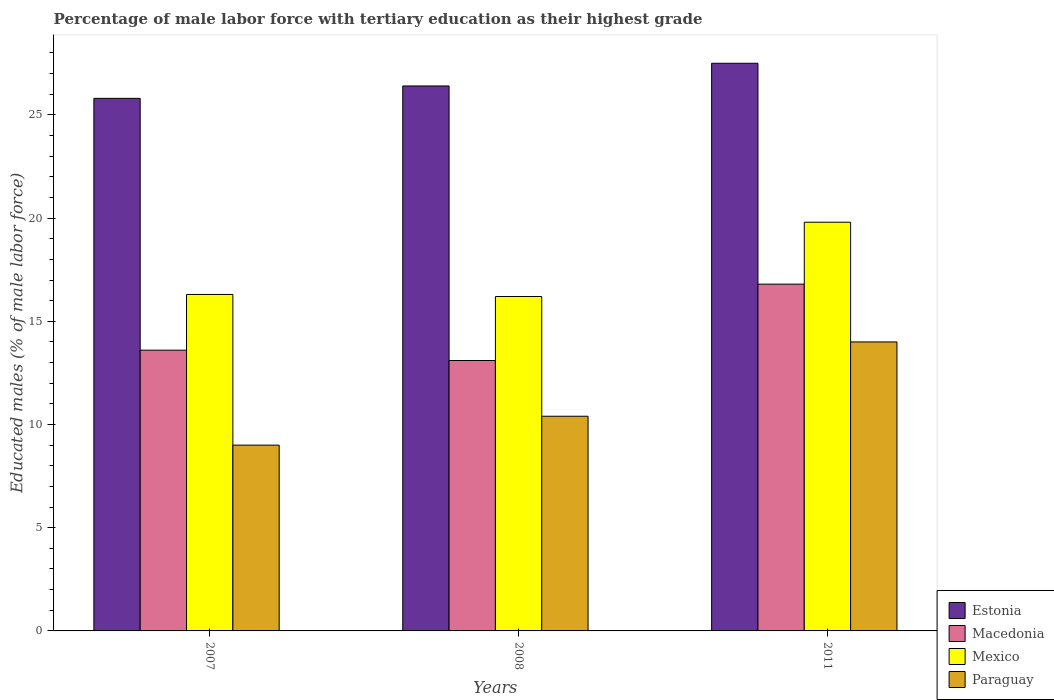How many different coloured bars are there?
Your answer should be compact. 4. Are the number of bars on each tick of the X-axis equal?
Your answer should be compact. Yes. In how many cases, is the number of bars for a given year not equal to the number of legend labels?
Keep it short and to the point. 0. What is the percentage of male labor force with tertiary education in Paraguay in 2011?
Your answer should be compact. 14. Across all years, what is the maximum percentage of male labor force with tertiary education in Macedonia?
Offer a very short reply. 16.8. Across all years, what is the minimum percentage of male labor force with tertiary education in Paraguay?
Offer a very short reply. 9. In which year was the percentage of male labor force with tertiary education in Macedonia maximum?
Offer a terse response. 2011. In which year was the percentage of male labor force with tertiary education in Mexico minimum?
Your response must be concise. 2008. What is the total percentage of male labor force with tertiary education in Macedonia in the graph?
Your answer should be compact. 43.5. What is the difference between the percentage of male labor force with tertiary education in Estonia in 2008 and that in 2011?
Offer a terse response. -1.1. What is the difference between the percentage of male labor force with tertiary education in Macedonia in 2007 and the percentage of male labor force with tertiary education in Mexico in 2011?
Provide a short and direct response. -6.2. What is the average percentage of male labor force with tertiary education in Estonia per year?
Your answer should be compact. 26.57. In the year 2008, what is the difference between the percentage of male labor force with tertiary education in Estonia and percentage of male labor force with tertiary education in Mexico?
Your answer should be very brief. 10.2. In how many years, is the percentage of male labor force with tertiary education in Estonia greater than 19 %?
Make the answer very short. 3. What is the ratio of the percentage of male labor force with tertiary education in Estonia in 2007 to that in 2008?
Give a very brief answer. 0.98. Is the percentage of male labor force with tertiary education in Paraguay in 2007 less than that in 2011?
Offer a terse response. Yes. What is the difference between the highest and the second highest percentage of male labor force with tertiary education in Paraguay?
Make the answer very short. 3.6. What is the difference between the highest and the lowest percentage of male labor force with tertiary education in Paraguay?
Ensure brevity in your answer.  5. What does the 2nd bar from the right in 2008 represents?
Offer a terse response. Mexico. Are all the bars in the graph horizontal?
Your answer should be very brief. No. How many years are there in the graph?
Offer a terse response. 3. Are the values on the major ticks of Y-axis written in scientific E-notation?
Make the answer very short. No. Does the graph contain any zero values?
Provide a succinct answer. No. Does the graph contain grids?
Give a very brief answer. No. How many legend labels are there?
Your response must be concise. 4. What is the title of the graph?
Offer a terse response. Percentage of male labor force with tertiary education as their highest grade. What is the label or title of the X-axis?
Ensure brevity in your answer.  Years. What is the label or title of the Y-axis?
Ensure brevity in your answer.  Educated males (% of male labor force). What is the Educated males (% of male labor force) of Estonia in 2007?
Provide a succinct answer. 25.8. What is the Educated males (% of male labor force) of Macedonia in 2007?
Your response must be concise. 13.6. What is the Educated males (% of male labor force) in Mexico in 2007?
Make the answer very short. 16.3. What is the Educated males (% of male labor force) in Estonia in 2008?
Give a very brief answer. 26.4. What is the Educated males (% of male labor force) in Macedonia in 2008?
Keep it short and to the point. 13.1. What is the Educated males (% of male labor force) in Mexico in 2008?
Offer a terse response. 16.2. What is the Educated males (% of male labor force) of Paraguay in 2008?
Provide a succinct answer. 10.4. What is the Educated males (% of male labor force) in Macedonia in 2011?
Ensure brevity in your answer.  16.8. What is the Educated males (% of male labor force) in Mexico in 2011?
Offer a terse response. 19.8. What is the Educated males (% of male labor force) in Paraguay in 2011?
Offer a terse response. 14. Across all years, what is the maximum Educated males (% of male labor force) of Estonia?
Provide a succinct answer. 27.5. Across all years, what is the maximum Educated males (% of male labor force) of Macedonia?
Provide a short and direct response. 16.8. Across all years, what is the maximum Educated males (% of male labor force) of Mexico?
Your answer should be very brief. 19.8. Across all years, what is the minimum Educated males (% of male labor force) of Estonia?
Your response must be concise. 25.8. Across all years, what is the minimum Educated males (% of male labor force) of Macedonia?
Keep it short and to the point. 13.1. Across all years, what is the minimum Educated males (% of male labor force) of Mexico?
Ensure brevity in your answer.  16.2. What is the total Educated males (% of male labor force) in Estonia in the graph?
Offer a very short reply. 79.7. What is the total Educated males (% of male labor force) of Macedonia in the graph?
Your answer should be compact. 43.5. What is the total Educated males (% of male labor force) of Mexico in the graph?
Make the answer very short. 52.3. What is the total Educated males (% of male labor force) of Paraguay in the graph?
Your answer should be compact. 33.4. What is the difference between the Educated males (% of male labor force) of Mexico in 2007 and that in 2008?
Provide a succinct answer. 0.1. What is the difference between the Educated males (% of male labor force) of Paraguay in 2007 and that in 2008?
Offer a terse response. -1.4. What is the difference between the Educated males (% of male labor force) in Estonia in 2007 and that in 2011?
Provide a short and direct response. -1.7. What is the difference between the Educated males (% of male labor force) of Mexico in 2007 and that in 2011?
Provide a short and direct response. -3.5. What is the difference between the Educated males (% of male labor force) of Paraguay in 2007 and that in 2011?
Make the answer very short. -5. What is the difference between the Educated males (% of male labor force) in Mexico in 2008 and that in 2011?
Offer a terse response. -3.6. What is the difference between the Educated males (% of male labor force) in Paraguay in 2008 and that in 2011?
Provide a short and direct response. -3.6. What is the difference between the Educated males (% of male labor force) in Estonia in 2007 and the Educated males (% of male labor force) in Mexico in 2008?
Offer a very short reply. 9.6. What is the difference between the Educated males (% of male labor force) of Estonia in 2007 and the Educated males (% of male labor force) of Paraguay in 2008?
Provide a succinct answer. 15.4. What is the difference between the Educated males (% of male labor force) of Macedonia in 2007 and the Educated males (% of male labor force) of Paraguay in 2008?
Give a very brief answer. 3.2. What is the difference between the Educated males (% of male labor force) in Estonia in 2007 and the Educated males (% of male labor force) in Macedonia in 2011?
Your response must be concise. 9. What is the difference between the Educated males (% of male labor force) of Macedonia in 2007 and the Educated males (% of male labor force) of Paraguay in 2011?
Provide a succinct answer. -0.4. What is the difference between the Educated males (% of male labor force) in Estonia in 2008 and the Educated males (% of male labor force) in Macedonia in 2011?
Provide a short and direct response. 9.6. What is the difference between the Educated males (% of male labor force) in Estonia in 2008 and the Educated males (% of male labor force) in Mexico in 2011?
Keep it short and to the point. 6.6. What is the difference between the Educated males (% of male labor force) in Estonia in 2008 and the Educated males (% of male labor force) in Paraguay in 2011?
Your response must be concise. 12.4. What is the difference between the Educated males (% of male labor force) of Macedonia in 2008 and the Educated males (% of male labor force) of Mexico in 2011?
Keep it short and to the point. -6.7. What is the difference between the Educated males (% of male labor force) of Macedonia in 2008 and the Educated males (% of male labor force) of Paraguay in 2011?
Make the answer very short. -0.9. What is the difference between the Educated males (% of male labor force) in Mexico in 2008 and the Educated males (% of male labor force) in Paraguay in 2011?
Give a very brief answer. 2.2. What is the average Educated males (% of male labor force) in Estonia per year?
Ensure brevity in your answer.  26.57. What is the average Educated males (% of male labor force) in Macedonia per year?
Give a very brief answer. 14.5. What is the average Educated males (% of male labor force) in Mexico per year?
Provide a succinct answer. 17.43. What is the average Educated males (% of male labor force) in Paraguay per year?
Provide a succinct answer. 11.13. In the year 2007, what is the difference between the Educated males (% of male labor force) in Estonia and Educated males (% of male labor force) in Mexico?
Keep it short and to the point. 9.5. In the year 2007, what is the difference between the Educated males (% of male labor force) in Macedonia and Educated males (% of male labor force) in Mexico?
Your answer should be very brief. -2.7. In the year 2007, what is the difference between the Educated males (% of male labor force) in Macedonia and Educated males (% of male labor force) in Paraguay?
Ensure brevity in your answer.  4.6. In the year 2007, what is the difference between the Educated males (% of male labor force) of Mexico and Educated males (% of male labor force) of Paraguay?
Give a very brief answer. 7.3. In the year 2008, what is the difference between the Educated males (% of male labor force) of Macedonia and Educated males (% of male labor force) of Mexico?
Ensure brevity in your answer.  -3.1. In the year 2008, what is the difference between the Educated males (% of male labor force) in Macedonia and Educated males (% of male labor force) in Paraguay?
Your answer should be compact. 2.7. In the year 2008, what is the difference between the Educated males (% of male labor force) of Mexico and Educated males (% of male labor force) of Paraguay?
Offer a terse response. 5.8. In the year 2011, what is the difference between the Educated males (% of male labor force) of Estonia and Educated males (% of male labor force) of Paraguay?
Offer a very short reply. 13.5. In the year 2011, what is the difference between the Educated males (% of male labor force) in Macedonia and Educated males (% of male labor force) in Mexico?
Your response must be concise. -3. In the year 2011, what is the difference between the Educated males (% of male labor force) of Macedonia and Educated males (% of male labor force) of Paraguay?
Give a very brief answer. 2.8. In the year 2011, what is the difference between the Educated males (% of male labor force) in Mexico and Educated males (% of male labor force) in Paraguay?
Keep it short and to the point. 5.8. What is the ratio of the Educated males (% of male labor force) in Estonia in 2007 to that in 2008?
Ensure brevity in your answer.  0.98. What is the ratio of the Educated males (% of male labor force) in Macedonia in 2007 to that in 2008?
Make the answer very short. 1.04. What is the ratio of the Educated males (% of male labor force) of Mexico in 2007 to that in 2008?
Keep it short and to the point. 1.01. What is the ratio of the Educated males (% of male labor force) of Paraguay in 2007 to that in 2008?
Your answer should be compact. 0.87. What is the ratio of the Educated males (% of male labor force) of Estonia in 2007 to that in 2011?
Your response must be concise. 0.94. What is the ratio of the Educated males (% of male labor force) of Macedonia in 2007 to that in 2011?
Offer a terse response. 0.81. What is the ratio of the Educated males (% of male labor force) in Mexico in 2007 to that in 2011?
Your response must be concise. 0.82. What is the ratio of the Educated males (% of male labor force) in Paraguay in 2007 to that in 2011?
Your answer should be compact. 0.64. What is the ratio of the Educated males (% of male labor force) of Macedonia in 2008 to that in 2011?
Provide a short and direct response. 0.78. What is the ratio of the Educated males (% of male labor force) of Mexico in 2008 to that in 2011?
Give a very brief answer. 0.82. What is the ratio of the Educated males (% of male labor force) of Paraguay in 2008 to that in 2011?
Your answer should be very brief. 0.74. What is the difference between the highest and the second highest Educated males (% of male labor force) in Macedonia?
Provide a short and direct response. 3.2. What is the difference between the highest and the lowest Educated males (% of male labor force) in Macedonia?
Give a very brief answer. 3.7. What is the difference between the highest and the lowest Educated males (% of male labor force) in Mexico?
Your answer should be very brief. 3.6. What is the difference between the highest and the lowest Educated males (% of male labor force) in Paraguay?
Provide a succinct answer. 5. 